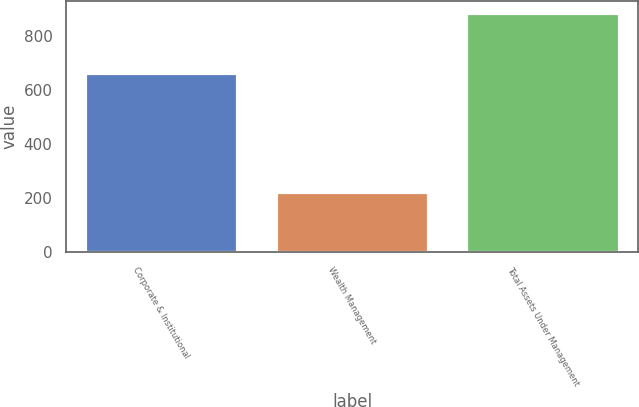<chart> <loc_0><loc_0><loc_500><loc_500><bar_chart><fcel>Corporate & Institutional<fcel>Wealth Management<fcel>Total Assets Under Management<nl><fcel>662.7<fcel>221.8<fcel>884.5<nl></chart> 